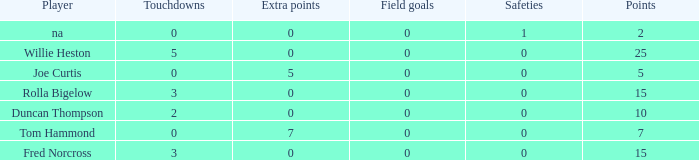How many Touchdowns have a Player of rolla bigelow, and an Extra points smaller than 0? None. 